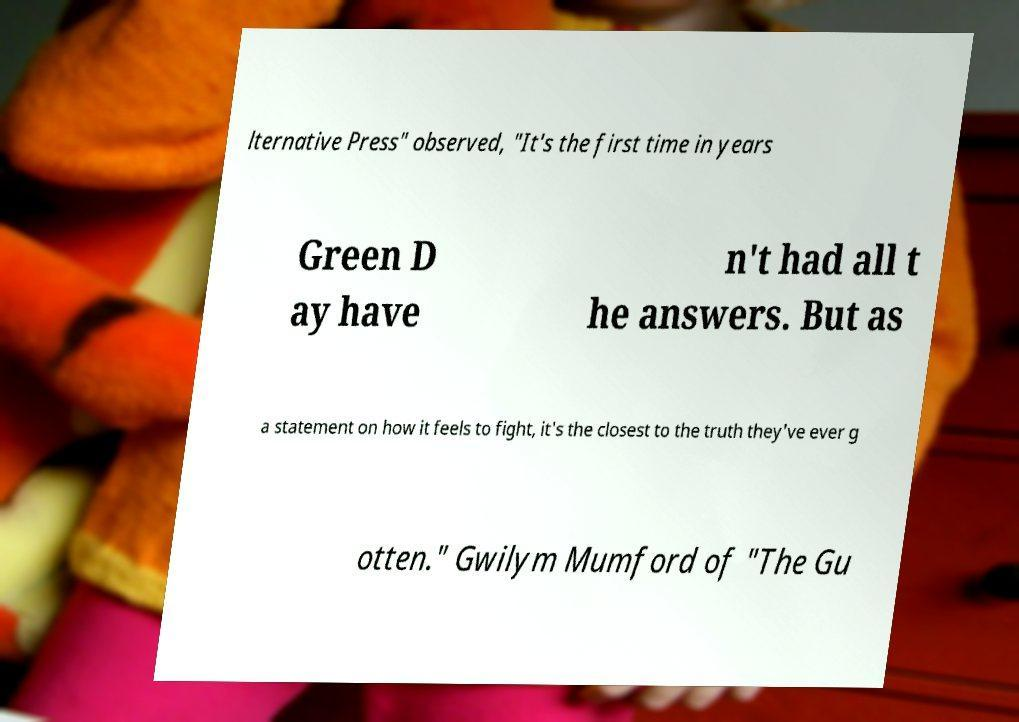Please read and relay the text visible in this image. What does it say? lternative Press" observed, "It's the first time in years Green D ay have n't had all t he answers. But as a statement on how it feels to fight, it's the closest to the truth they've ever g otten." Gwilym Mumford of "The Gu 